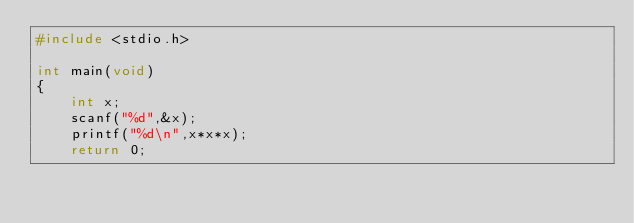Convert code to text. <code><loc_0><loc_0><loc_500><loc_500><_C_>#include <stdio.h>

int main(void)
{
	int x;
	scanf("%d",&x);
	printf("%d\n",x*x*x);
	return 0;</code> 